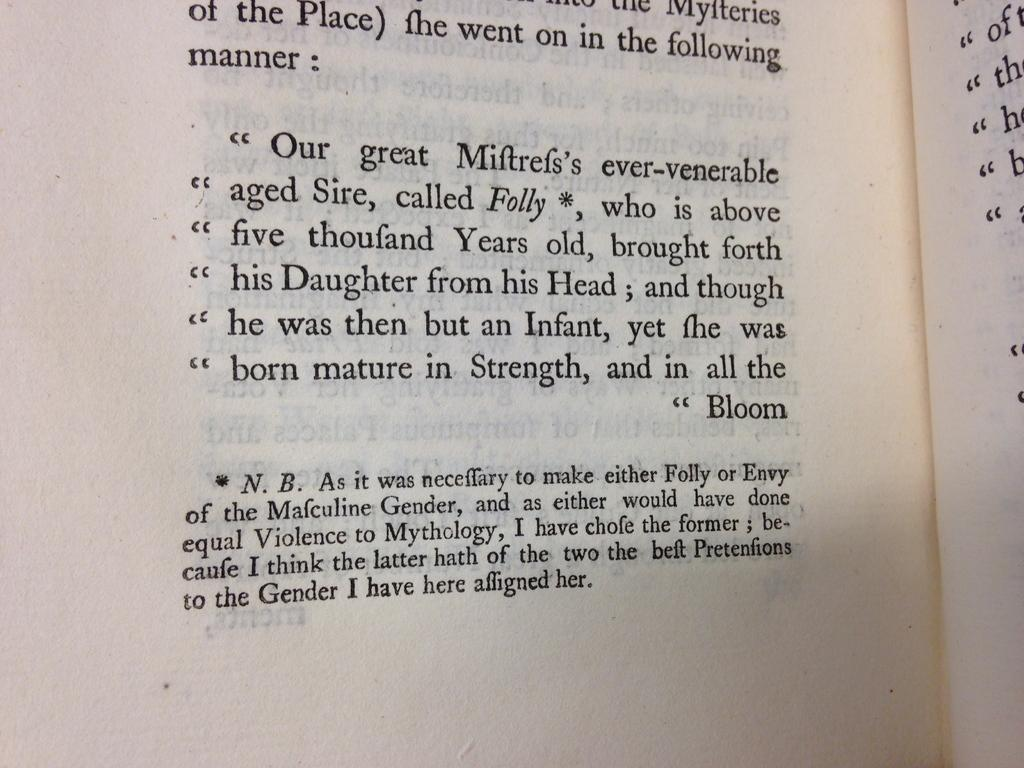Provide a one-sentence caption for the provided image. A book includes a footnote about choosing genders for different mythological characters. 